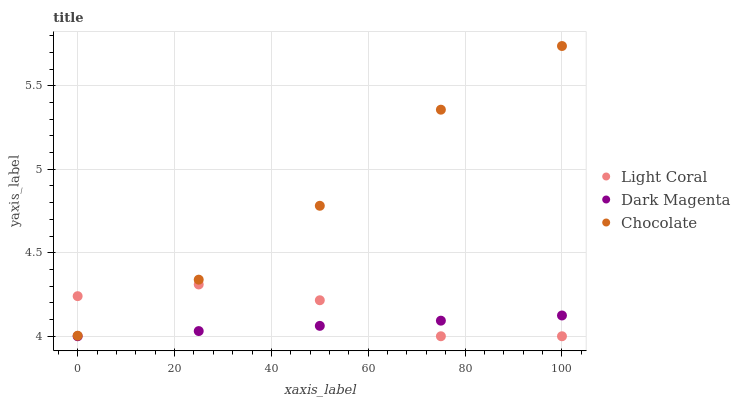Does Dark Magenta have the minimum area under the curve?
Answer yes or no. Yes. Does Chocolate have the maximum area under the curve?
Answer yes or no. Yes. Does Chocolate have the minimum area under the curve?
Answer yes or no. No. Does Dark Magenta have the maximum area under the curve?
Answer yes or no. No. Is Dark Magenta the smoothest?
Answer yes or no. Yes. Is Light Coral the roughest?
Answer yes or no. Yes. Is Chocolate the smoothest?
Answer yes or no. No. Is Chocolate the roughest?
Answer yes or no. No. Does Light Coral have the lowest value?
Answer yes or no. Yes. Does Chocolate have the lowest value?
Answer yes or no. No. Does Chocolate have the highest value?
Answer yes or no. Yes. Does Dark Magenta have the highest value?
Answer yes or no. No. Is Dark Magenta less than Chocolate?
Answer yes or no. Yes. Is Chocolate greater than Dark Magenta?
Answer yes or no. Yes. Does Light Coral intersect Chocolate?
Answer yes or no. Yes. Is Light Coral less than Chocolate?
Answer yes or no. No. Is Light Coral greater than Chocolate?
Answer yes or no. No. Does Dark Magenta intersect Chocolate?
Answer yes or no. No. 